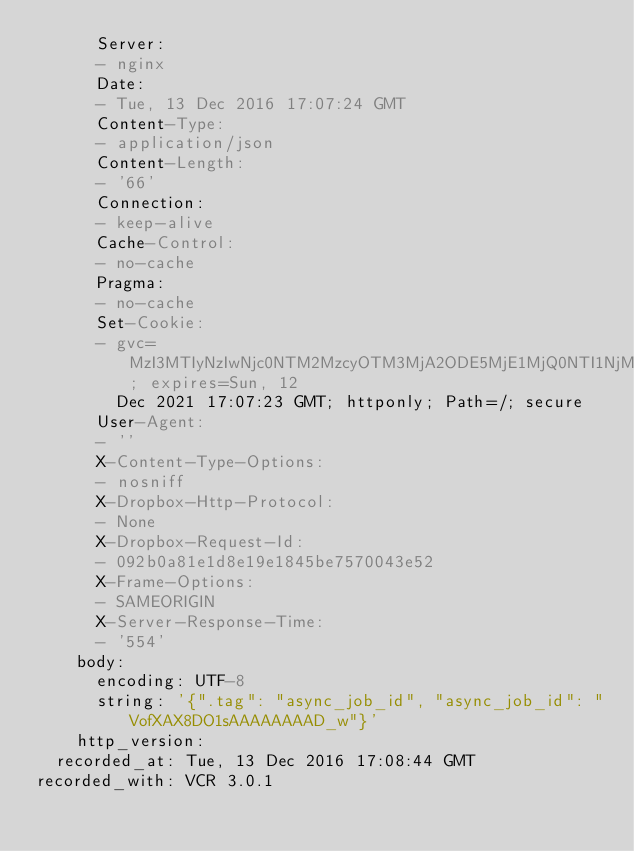<code> <loc_0><loc_0><loc_500><loc_500><_YAML_>      Server:
      - nginx
      Date:
      - Tue, 13 Dec 2016 17:07:24 GMT
      Content-Type:
      - application/json
      Content-Length:
      - '66'
      Connection:
      - keep-alive
      Cache-Control:
      - no-cache
      Pragma:
      - no-cache
      Set-Cookie:
      - gvc=MzI3MTIyNzIwNjc0NTM2MzcyOTM3MjA2ODE5MjE1MjQ0NTI1NjMw; expires=Sun, 12
        Dec 2021 17:07:23 GMT; httponly; Path=/; secure
      User-Agent:
      - ''
      X-Content-Type-Options:
      - nosniff
      X-Dropbox-Http-Protocol:
      - None
      X-Dropbox-Request-Id:
      - 092b0a81e1d8e19e1845be7570043e52
      X-Frame-Options:
      - SAMEORIGIN
      X-Server-Response-Time:
      - '554'
    body:
      encoding: UTF-8
      string: '{".tag": "async_job_id", "async_job_id": "VofXAX8DO1sAAAAAAAAD_w"}'
    http_version:
  recorded_at: Tue, 13 Dec 2016 17:08:44 GMT
recorded_with: VCR 3.0.1
</code> 